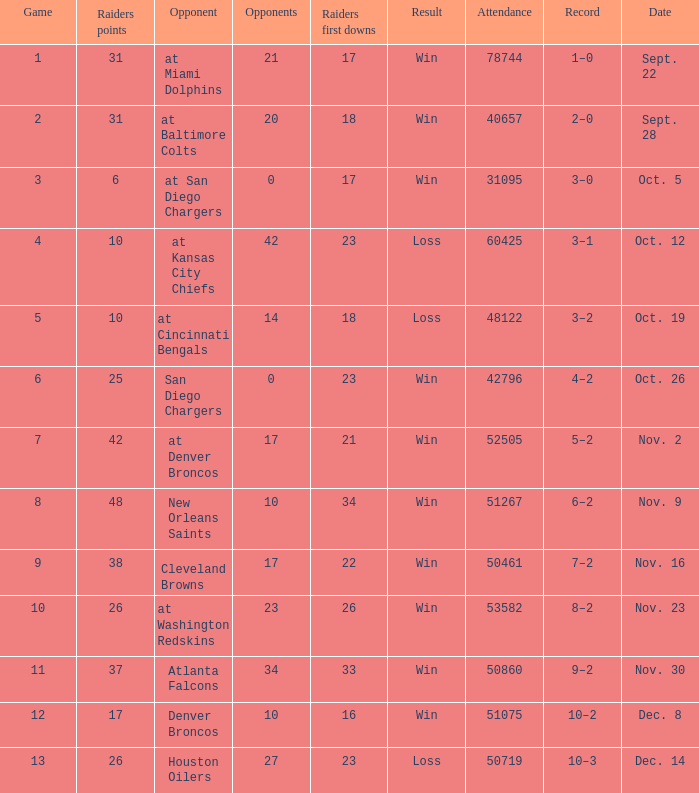How many opponents played 1 game with a result win? 21.0. 